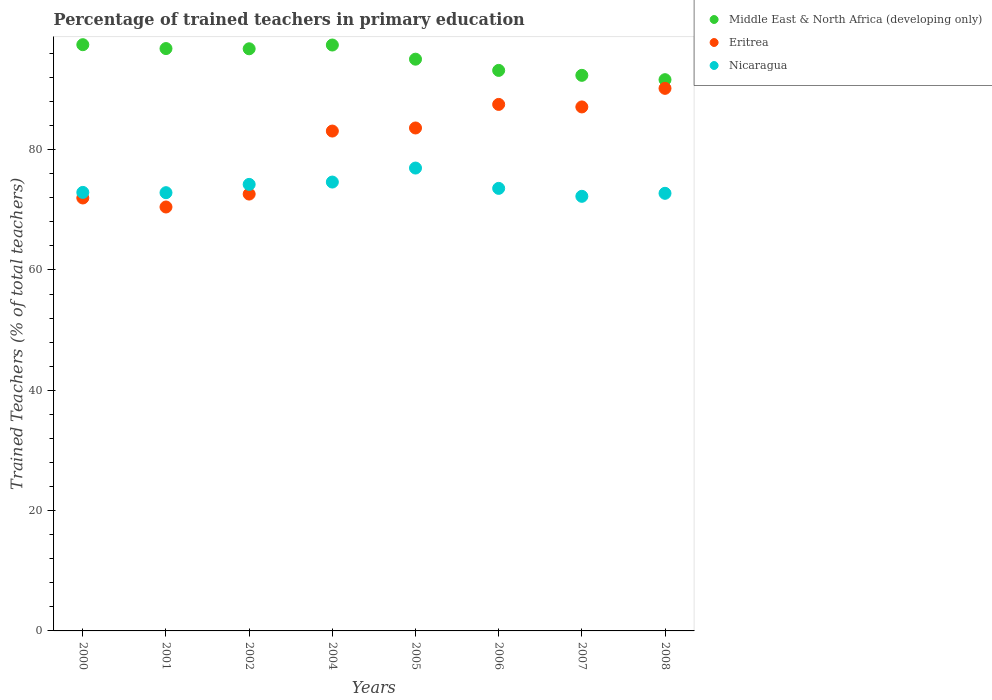What is the percentage of trained teachers in Nicaragua in 2002?
Provide a succinct answer. 74.23. Across all years, what is the maximum percentage of trained teachers in Middle East & North Africa (developing only)?
Offer a terse response. 97.45. Across all years, what is the minimum percentage of trained teachers in Eritrea?
Offer a terse response. 70.47. In which year was the percentage of trained teachers in Middle East & North Africa (developing only) minimum?
Your response must be concise. 2008. What is the total percentage of trained teachers in Middle East & North Africa (developing only) in the graph?
Give a very brief answer. 760.64. What is the difference between the percentage of trained teachers in Nicaragua in 2005 and that in 2007?
Your response must be concise. 4.7. What is the difference between the percentage of trained teachers in Nicaragua in 2006 and the percentage of trained teachers in Middle East & North Africa (developing only) in 2008?
Offer a terse response. -18.07. What is the average percentage of trained teachers in Nicaragua per year?
Keep it short and to the point. 73.76. In the year 2002, what is the difference between the percentage of trained teachers in Middle East & North Africa (developing only) and percentage of trained teachers in Nicaragua?
Ensure brevity in your answer.  22.54. What is the ratio of the percentage of trained teachers in Eritrea in 2000 to that in 2001?
Your response must be concise. 1.02. What is the difference between the highest and the second highest percentage of trained teachers in Middle East & North Africa (developing only)?
Keep it short and to the point. 0.06. What is the difference between the highest and the lowest percentage of trained teachers in Middle East & North Africa (developing only)?
Ensure brevity in your answer.  5.82. In how many years, is the percentage of trained teachers in Eritrea greater than the average percentage of trained teachers in Eritrea taken over all years?
Provide a succinct answer. 5. Is the sum of the percentage of trained teachers in Nicaragua in 2005 and 2008 greater than the maximum percentage of trained teachers in Middle East & North Africa (developing only) across all years?
Give a very brief answer. Yes. How many dotlines are there?
Make the answer very short. 3. How many years are there in the graph?
Provide a succinct answer. 8. Are the values on the major ticks of Y-axis written in scientific E-notation?
Offer a terse response. No. Does the graph contain grids?
Provide a succinct answer. No. Where does the legend appear in the graph?
Ensure brevity in your answer.  Top right. How many legend labels are there?
Give a very brief answer. 3. What is the title of the graph?
Offer a very short reply. Percentage of trained teachers in primary education. What is the label or title of the Y-axis?
Offer a very short reply. Trained Teachers (% of total teachers). What is the Trained Teachers (% of total teachers) in Middle East & North Africa (developing only) in 2000?
Ensure brevity in your answer.  97.45. What is the Trained Teachers (% of total teachers) of Eritrea in 2000?
Offer a terse response. 71.97. What is the Trained Teachers (% of total teachers) of Nicaragua in 2000?
Make the answer very short. 72.9. What is the Trained Teachers (% of total teachers) in Middle East & North Africa (developing only) in 2001?
Offer a terse response. 96.81. What is the Trained Teachers (% of total teachers) of Eritrea in 2001?
Your answer should be very brief. 70.47. What is the Trained Teachers (% of total teachers) of Nicaragua in 2001?
Make the answer very short. 72.85. What is the Trained Teachers (% of total teachers) of Middle East & North Africa (developing only) in 2002?
Offer a terse response. 96.77. What is the Trained Teachers (% of total teachers) of Eritrea in 2002?
Offer a terse response. 72.62. What is the Trained Teachers (% of total teachers) of Nicaragua in 2002?
Your answer should be compact. 74.23. What is the Trained Teachers (% of total teachers) in Middle East & North Africa (developing only) in 2004?
Give a very brief answer. 97.4. What is the Trained Teachers (% of total teachers) of Eritrea in 2004?
Your response must be concise. 83.09. What is the Trained Teachers (% of total teachers) in Nicaragua in 2004?
Provide a succinct answer. 74.62. What is the Trained Teachers (% of total teachers) of Middle East & North Africa (developing only) in 2005?
Make the answer very short. 95.04. What is the Trained Teachers (% of total teachers) in Eritrea in 2005?
Make the answer very short. 83.61. What is the Trained Teachers (% of total teachers) of Nicaragua in 2005?
Keep it short and to the point. 76.94. What is the Trained Teachers (% of total teachers) in Middle East & North Africa (developing only) in 2006?
Give a very brief answer. 93.18. What is the Trained Teachers (% of total teachers) in Eritrea in 2006?
Make the answer very short. 87.52. What is the Trained Teachers (% of total teachers) in Nicaragua in 2006?
Give a very brief answer. 73.57. What is the Trained Teachers (% of total teachers) in Middle East & North Africa (developing only) in 2007?
Offer a very short reply. 92.36. What is the Trained Teachers (% of total teachers) in Eritrea in 2007?
Provide a succinct answer. 87.11. What is the Trained Teachers (% of total teachers) in Nicaragua in 2007?
Provide a short and direct response. 72.25. What is the Trained Teachers (% of total teachers) of Middle East & North Africa (developing only) in 2008?
Offer a very short reply. 91.64. What is the Trained Teachers (% of total teachers) of Eritrea in 2008?
Provide a succinct answer. 90.19. What is the Trained Teachers (% of total teachers) in Nicaragua in 2008?
Offer a very short reply. 72.74. Across all years, what is the maximum Trained Teachers (% of total teachers) of Middle East & North Africa (developing only)?
Give a very brief answer. 97.45. Across all years, what is the maximum Trained Teachers (% of total teachers) in Eritrea?
Give a very brief answer. 90.19. Across all years, what is the maximum Trained Teachers (% of total teachers) in Nicaragua?
Make the answer very short. 76.94. Across all years, what is the minimum Trained Teachers (% of total teachers) of Middle East & North Africa (developing only)?
Make the answer very short. 91.64. Across all years, what is the minimum Trained Teachers (% of total teachers) in Eritrea?
Keep it short and to the point. 70.47. Across all years, what is the minimum Trained Teachers (% of total teachers) of Nicaragua?
Offer a terse response. 72.25. What is the total Trained Teachers (% of total teachers) of Middle East & North Africa (developing only) in the graph?
Make the answer very short. 760.64. What is the total Trained Teachers (% of total teachers) of Eritrea in the graph?
Provide a succinct answer. 646.58. What is the total Trained Teachers (% of total teachers) of Nicaragua in the graph?
Make the answer very short. 590.09. What is the difference between the Trained Teachers (% of total teachers) of Middle East & North Africa (developing only) in 2000 and that in 2001?
Your response must be concise. 0.64. What is the difference between the Trained Teachers (% of total teachers) of Eritrea in 2000 and that in 2001?
Give a very brief answer. 1.5. What is the difference between the Trained Teachers (% of total teachers) in Nicaragua in 2000 and that in 2001?
Your answer should be very brief. 0.05. What is the difference between the Trained Teachers (% of total teachers) of Middle East & North Africa (developing only) in 2000 and that in 2002?
Provide a succinct answer. 0.68. What is the difference between the Trained Teachers (% of total teachers) in Eritrea in 2000 and that in 2002?
Ensure brevity in your answer.  -0.65. What is the difference between the Trained Teachers (% of total teachers) of Nicaragua in 2000 and that in 2002?
Your answer should be compact. -1.33. What is the difference between the Trained Teachers (% of total teachers) of Middle East & North Africa (developing only) in 2000 and that in 2004?
Your answer should be compact. 0.06. What is the difference between the Trained Teachers (% of total teachers) in Eritrea in 2000 and that in 2004?
Give a very brief answer. -11.12. What is the difference between the Trained Teachers (% of total teachers) in Nicaragua in 2000 and that in 2004?
Keep it short and to the point. -1.72. What is the difference between the Trained Teachers (% of total teachers) in Middle East & North Africa (developing only) in 2000 and that in 2005?
Make the answer very short. 2.41. What is the difference between the Trained Teachers (% of total teachers) of Eritrea in 2000 and that in 2005?
Make the answer very short. -11.64. What is the difference between the Trained Teachers (% of total teachers) of Nicaragua in 2000 and that in 2005?
Keep it short and to the point. -4.05. What is the difference between the Trained Teachers (% of total teachers) in Middle East & North Africa (developing only) in 2000 and that in 2006?
Your response must be concise. 4.27. What is the difference between the Trained Teachers (% of total teachers) in Eritrea in 2000 and that in 2006?
Your answer should be compact. -15.55. What is the difference between the Trained Teachers (% of total teachers) of Nicaragua in 2000 and that in 2006?
Offer a terse response. -0.67. What is the difference between the Trained Teachers (% of total teachers) of Middle East & North Africa (developing only) in 2000 and that in 2007?
Your response must be concise. 5.1. What is the difference between the Trained Teachers (% of total teachers) of Eritrea in 2000 and that in 2007?
Offer a terse response. -15.14. What is the difference between the Trained Teachers (% of total teachers) in Nicaragua in 2000 and that in 2007?
Offer a very short reply. 0.65. What is the difference between the Trained Teachers (% of total teachers) in Middle East & North Africa (developing only) in 2000 and that in 2008?
Provide a succinct answer. 5.82. What is the difference between the Trained Teachers (% of total teachers) in Eritrea in 2000 and that in 2008?
Your response must be concise. -18.22. What is the difference between the Trained Teachers (% of total teachers) in Nicaragua in 2000 and that in 2008?
Your answer should be very brief. 0.15. What is the difference between the Trained Teachers (% of total teachers) of Middle East & North Africa (developing only) in 2001 and that in 2002?
Offer a terse response. 0.04. What is the difference between the Trained Teachers (% of total teachers) of Eritrea in 2001 and that in 2002?
Ensure brevity in your answer.  -2.15. What is the difference between the Trained Teachers (% of total teachers) in Nicaragua in 2001 and that in 2002?
Offer a terse response. -1.38. What is the difference between the Trained Teachers (% of total teachers) of Middle East & North Africa (developing only) in 2001 and that in 2004?
Your answer should be very brief. -0.59. What is the difference between the Trained Teachers (% of total teachers) in Eritrea in 2001 and that in 2004?
Give a very brief answer. -12.62. What is the difference between the Trained Teachers (% of total teachers) of Nicaragua in 2001 and that in 2004?
Offer a terse response. -1.77. What is the difference between the Trained Teachers (% of total teachers) in Middle East & North Africa (developing only) in 2001 and that in 2005?
Offer a very short reply. 1.76. What is the difference between the Trained Teachers (% of total teachers) in Eritrea in 2001 and that in 2005?
Offer a terse response. -13.14. What is the difference between the Trained Teachers (% of total teachers) of Nicaragua in 2001 and that in 2005?
Provide a short and direct response. -4.09. What is the difference between the Trained Teachers (% of total teachers) of Middle East & North Africa (developing only) in 2001 and that in 2006?
Keep it short and to the point. 3.63. What is the difference between the Trained Teachers (% of total teachers) in Eritrea in 2001 and that in 2006?
Your answer should be compact. -17.05. What is the difference between the Trained Teachers (% of total teachers) of Nicaragua in 2001 and that in 2006?
Provide a short and direct response. -0.72. What is the difference between the Trained Teachers (% of total teachers) in Middle East & North Africa (developing only) in 2001 and that in 2007?
Keep it short and to the point. 4.45. What is the difference between the Trained Teachers (% of total teachers) of Eritrea in 2001 and that in 2007?
Your response must be concise. -16.63. What is the difference between the Trained Teachers (% of total teachers) of Nicaragua in 2001 and that in 2007?
Provide a succinct answer. 0.6. What is the difference between the Trained Teachers (% of total teachers) of Middle East & North Africa (developing only) in 2001 and that in 2008?
Keep it short and to the point. 5.17. What is the difference between the Trained Teachers (% of total teachers) in Eritrea in 2001 and that in 2008?
Offer a terse response. -19.72. What is the difference between the Trained Teachers (% of total teachers) in Nicaragua in 2001 and that in 2008?
Offer a terse response. 0.11. What is the difference between the Trained Teachers (% of total teachers) of Middle East & North Africa (developing only) in 2002 and that in 2004?
Your answer should be compact. -0.63. What is the difference between the Trained Teachers (% of total teachers) in Eritrea in 2002 and that in 2004?
Your answer should be compact. -10.48. What is the difference between the Trained Teachers (% of total teachers) in Nicaragua in 2002 and that in 2004?
Provide a succinct answer. -0.39. What is the difference between the Trained Teachers (% of total teachers) in Middle East & North Africa (developing only) in 2002 and that in 2005?
Give a very brief answer. 1.73. What is the difference between the Trained Teachers (% of total teachers) in Eritrea in 2002 and that in 2005?
Provide a succinct answer. -10.99. What is the difference between the Trained Teachers (% of total teachers) in Nicaragua in 2002 and that in 2005?
Provide a succinct answer. -2.72. What is the difference between the Trained Teachers (% of total teachers) of Middle East & North Africa (developing only) in 2002 and that in 2006?
Offer a terse response. 3.59. What is the difference between the Trained Teachers (% of total teachers) of Eritrea in 2002 and that in 2006?
Offer a terse response. -14.9. What is the difference between the Trained Teachers (% of total teachers) of Nicaragua in 2002 and that in 2006?
Make the answer very short. 0.66. What is the difference between the Trained Teachers (% of total teachers) in Middle East & North Africa (developing only) in 2002 and that in 2007?
Your answer should be compact. 4.41. What is the difference between the Trained Teachers (% of total teachers) in Eritrea in 2002 and that in 2007?
Offer a terse response. -14.49. What is the difference between the Trained Teachers (% of total teachers) in Nicaragua in 2002 and that in 2007?
Ensure brevity in your answer.  1.98. What is the difference between the Trained Teachers (% of total teachers) in Middle East & North Africa (developing only) in 2002 and that in 2008?
Give a very brief answer. 5.13. What is the difference between the Trained Teachers (% of total teachers) in Eritrea in 2002 and that in 2008?
Provide a short and direct response. -17.57. What is the difference between the Trained Teachers (% of total teachers) of Nicaragua in 2002 and that in 2008?
Provide a succinct answer. 1.48. What is the difference between the Trained Teachers (% of total teachers) of Middle East & North Africa (developing only) in 2004 and that in 2005?
Offer a very short reply. 2.35. What is the difference between the Trained Teachers (% of total teachers) in Eritrea in 2004 and that in 2005?
Make the answer very short. -0.51. What is the difference between the Trained Teachers (% of total teachers) in Nicaragua in 2004 and that in 2005?
Your answer should be compact. -2.33. What is the difference between the Trained Teachers (% of total teachers) of Middle East & North Africa (developing only) in 2004 and that in 2006?
Your response must be concise. 4.22. What is the difference between the Trained Teachers (% of total teachers) in Eritrea in 2004 and that in 2006?
Offer a very short reply. -4.43. What is the difference between the Trained Teachers (% of total teachers) in Nicaragua in 2004 and that in 2006?
Ensure brevity in your answer.  1.05. What is the difference between the Trained Teachers (% of total teachers) of Middle East & North Africa (developing only) in 2004 and that in 2007?
Give a very brief answer. 5.04. What is the difference between the Trained Teachers (% of total teachers) of Eritrea in 2004 and that in 2007?
Your response must be concise. -4.01. What is the difference between the Trained Teachers (% of total teachers) in Nicaragua in 2004 and that in 2007?
Give a very brief answer. 2.37. What is the difference between the Trained Teachers (% of total teachers) of Middle East & North Africa (developing only) in 2004 and that in 2008?
Provide a succinct answer. 5.76. What is the difference between the Trained Teachers (% of total teachers) of Eritrea in 2004 and that in 2008?
Give a very brief answer. -7.1. What is the difference between the Trained Teachers (% of total teachers) in Nicaragua in 2004 and that in 2008?
Your response must be concise. 1.87. What is the difference between the Trained Teachers (% of total teachers) of Middle East & North Africa (developing only) in 2005 and that in 2006?
Make the answer very short. 1.86. What is the difference between the Trained Teachers (% of total teachers) in Eritrea in 2005 and that in 2006?
Give a very brief answer. -3.92. What is the difference between the Trained Teachers (% of total teachers) in Nicaragua in 2005 and that in 2006?
Keep it short and to the point. 3.38. What is the difference between the Trained Teachers (% of total teachers) in Middle East & North Africa (developing only) in 2005 and that in 2007?
Offer a very short reply. 2.69. What is the difference between the Trained Teachers (% of total teachers) in Eritrea in 2005 and that in 2007?
Offer a terse response. -3.5. What is the difference between the Trained Teachers (% of total teachers) of Nicaragua in 2005 and that in 2007?
Offer a very short reply. 4.7. What is the difference between the Trained Teachers (% of total teachers) of Middle East & North Africa (developing only) in 2005 and that in 2008?
Make the answer very short. 3.41. What is the difference between the Trained Teachers (% of total teachers) of Eritrea in 2005 and that in 2008?
Ensure brevity in your answer.  -6.59. What is the difference between the Trained Teachers (% of total teachers) of Nicaragua in 2005 and that in 2008?
Provide a succinct answer. 4.2. What is the difference between the Trained Teachers (% of total teachers) of Middle East & North Africa (developing only) in 2006 and that in 2007?
Give a very brief answer. 0.82. What is the difference between the Trained Teachers (% of total teachers) in Eritrea in 2006 and that in 2007?
Provide a short and direct response. 0.42. What is the difference between the Trained Teachers (% of total teachers) in Nicaragua in 2006 and that in 2007?
Your answer should be compact. 1.32. What is the difference between the Trained Teachers (% of total teachers) in Middle East & North Africa (developing only) in 2006 and that in 2008?
Ensure brevity in your answer.  1.54. What is the difference between the Trained Teachers (% of total teachers) in Eritrea in 2006 and that in 2008?
Provide a succinct answer. -2.67. What is the difference between the Trained Teachers (% of total teachers) in Nicaragua in 2006 and that in 2008?
Offer a terse response. 0.82. What is the difference between the Trained Teachers (% of total teachers) of Middle East & North Africa (developing only) in 2007 and that in 2008?
Provide a short and direct response. 0.72. What is the difference between the Trained Teachers (% of total teachers) in Eritrea in 2007 and that in 2008?
Give a very brief answer. -3.09. What is the difference between the Trained Teachers (% of total teachers) in Nicaragua in 2007 and that in 2008?
Give a very brief answer. -0.5. What is the difference between the Trained Teachers (% of total teachers) of Middle East & North Africa (developing only) in 2000 and the Trained Teachers (% of total teachers) of Eritrea in 2001?
Provide a short and direct response. 26.98. What is the difference between the Trained Teachers (% of total teachers) in Middle East & North Africa (developing only) in 2000 and the Trained Teachers (% of total teachers) in Nicaragua in 2001?
Keep it short and to the point. 24.6. What is the difference between the Trained Teachers (% of total teachers) in Eritrea in 2000 and the Trained Teachers (% of total teachers) in Nicaragua in 2001?
Your answer should be very brief. -0.88. What is the difference between the Trained Teachers (% of total teachers) of Middle East & North Africa (developing only) in 2000 and the Trained Teachers (% of total teachers) of Eritrea in 2002?
Provide a short and direct response. 24.83. What is the difference between the Trained Teachers (% of total teachers) of Middle East & North Africa (developing only) in 2000 and the Trained Teachers (% of total teachers) of Nicaragua in 2002?
Make the answer very short. 23.22. What is the difference between the Trained Teachers (% of total teachers) of Eritrea in 2000 and the Trained Teachers (% of total teachers) of Nicaragua in 2002?
Offer a very short reply. -2.26. What is the difference between the Trained Teachers (% of total teachers) of Middle East & North Africa (developing only) in 2000 and the Trained Teachers (% of total teachers) of Eritrea in 2004?
Provide a succinct answer. 14.36. What is the difference between the Trained Teachers (% of total teachers) in Middle East & North Africa (developing only) in 2000 and the Trained Teachers (% of total teachers) in Nicaragua in 2004?
Provide a succinct answer. 22.84. What is the difference between the Trained Teachers (% of total teachers) in Eritrea in 2000 and the Trained Teachers (% of total teachers) in Nicaragua in 2004?
Your response must be concise. -2.65. What is the difference between the Trained Teachers (% of total teachers) of Middle East & North Africa (developing only) in 2000 and the Trained Teachers (% of total teachers) of Eritrea in 2005?
Offer a terse response. 13.85. What is the difference between the Trained Teachers (% of total teachers) of Middle East & North Africa (developing only) in 2000 and the Trained Teachers (% of total teachers) of Nicaragua in 2005?
Provide a succinct answer. 20.51. What is the difference between the Trained Teachers (% of total teachers) of Eritrea in 2000 and the Trained Teachers (% of total teachers) of Nicaragua in 2005?
Offer a very short reply. -4.98. What is the difference between the Trained Teachers (% of total teachers) of Middle East & North Africa (developing only) in 2000 and the Trained Teachers (% of total teachers) of Eritrea in 2006?
Your response must be concise. 9.93. What is the difference between the Trained Teachers (% of total teachers) in Middle East & North Africa (developing only) in 2000 and the Trained Teachers (% of total teachers) in Nicaragua in 2006?
Give a very brief answer. 23.89. What is the difference between the Trained Teachers (% of total teachers) in Eritrea in 2000 and the Trained Teachers (% of total teachers) in Nicaragua in 2006?
Your answer should be very brief. -1.6. What is the difference between the Trained Teachers (% of total teachers) in Middle East & North Africa (developing only) in 2000 and the Trained Teachers (% of total teachers) in Eritrea in 2007?
Give a very brief answer. 10.35. What is the difference between the Trained Teachers (% of total teachers) of Middle East & North Africa (developing only) in 2000 and the Trained Teachers (% of total teachers) of Nicaragua in 2007?
Offer a very short reply. 25.21. What is the difference between the Trained Teachers (% of total teachers) of Eritrea in 2000 and the Trained Teachers (% of total teachers) of Nicaragua in 2007?
Offer a very short reply. -0.28. What is the difference between the Trained Teachers (% of total teachers) in Middle East & North Africa (developing only) in 2000 and the Trained Teachers (% of total teachers) in Eritrea in 2008?
Your response must be concise. 7.26. What is the difference between the Trained Teachers (% of total teachers) in Middle East & North Africa (developing only) in 2000 and the Trained Teachers (% of total teachers) in Nicaragua in 2008?
Your response must be concise. 24.71. What is the difference between the Trained Teachers (% of total teachers) of Eritrea in 2000 and the Trained Teachers (% of total teachers) of Nicaragua in 2008?
Your answer should be very brief. -0.77. What is the difference between the Trained Teachers (% of total teachers) in Middle East & North Africa (developing only) in 2001 and the Trained Teachers (% of total teachers) in Eritrea in 2002?
Keep it short and to the point. 24.19. What is the difference between the Trained Teachers (% of total teachers) of Middle East & North Africa (developing only) in 2001 and the Trained Teachers (% of total teachers) of Nicaragua in 2002?
Your response must be concise. 22.58. What is the difference between the Trained Teachers (% of total teachers) in Eritrea in 2001 and the Trained Teachers (% of total teachers) in Nicaragua in 2002?
Give a very brief answer. -3.76. What is the difference between the Trained Teachers (% of total teachers) of Middle East & North Africa (developing only) in 2001 and the Trained Teachers (% of total teachers) of Eritrea in 2004?
Your response must be concise. 13.71. What is the difference between the Trained Teachers (% of total teachers) in Middle East & North Africa (developing only) in 2001 and the Trained Teachers (% of total teachers) in Nicaragua in 2004?
Offer a very short reply. 22.19. What is the difference between the Trained Teachers (% of total teachers) of Eritrea in 2001 and the Trained Teachers (% of total teachers) of Nicaragua in 2004?
Offer a terse response. -4.15. What is the difference between the Trained Teachers (% of total teachers) in Middle East & North Africa (developing only) in 2001 and the Trained Teachers (% of total teachers) in Eritrea in 2005?
Give a very brief answer. 13.2. What is the difference between the Trained Teachers (% of total teachers) in Middle East & North Africa (developing only) in 2001 and the Trained Teachers (% of total teachers) in Nicaragua in 2005?
Your response must be concise. 19.86. What is the difference between the Trained Teachers (% of total teachers) in Eritrea in 2001 and the Trained Teachers (% of total teachers) in Nicaragua in 2005?
Your response must be concise. -6.47. What is the difference between the Trained Teachers (% of total teachers) of Middle East & North Africa (developing only) in 2001 and the Trained Teachers (% of total teachers) of Eritrea in 2006?
Your answer should be compact. 9.28. What is the difference between the Trained Teachers (% of total teachers) of Middle East & North Africa (developing only) in 2001 and the Trained Teachers (% of total teachers) of Nicaragua in 2006?
Your answer should be compact. 23.24. What is the difference between the Trained Teachers (% of total teachers) of Eritrea in 2001 and the Trained Teachers (% of total teachers) of Nicaragua in 2006?
Offer a terse response. -3.1. What is the difference between the Trained Teachers (% of total teachers) in Middle East & North Africa (developing only) in 2001 and the Trained Teachers (% of total teachers) in Eritrea in 2007?
Your answer should be compact. 9.7. What is the difference between the Trained Teachers (% of total teachers) of Middle East & North Africa (developing only) in 2001 and the Trained Teachers (% of total teachers) of Nicaragua in 2007?
Ensure brevity in your answer.  24.56. What is the difference between the Trained Teachers (% of total teachers) in Eritrea in 2001 and the Trained Teachers (% of total teachers) in Nicaragua in 2007?
Offer a terse response. -1.77. What is the difference between the Trained Teachers (% of total teachers) of Middle East & North Africa (developing only) in 2001 and the Trained Teachers (% of total teachers) of Eritrea in 2008?
Ensure brevity in your answer.  6.61. What is the difference between the Trained Teachers (% of total teachers) in Middle East & North Africa (developing only) in 2001 and the Trained Teachers (% of total teachers) in Nicaragua in 2008?
Offer a terse response. 24.06. What is the difference between the Trained Teachers (% of total teachers) of Eritrea in 2001 and the Trained Teachers (% of total teachers) of Nicaragua in 2008?
Offer a very short reply. -2.27. What is the difference between the Trained Teachers (% of total teachers) of Middle East & North Africa (developing only) in 2002 and the Trained Teachers (% of total teachers) of Eritrea in 2004?
Offer a very short reply. 13.68. What is the difference between the Trained Teachers (% of total teachers) of Middle East & North Africa (developing only) in 2002 and the Trained Teachers (% of total teachers) of Nicaragua in 2004?
Offer a very short reply. 22.15. What is the difference between the Trained Teachers (% of total teachers) of Eritrea in 2002 and the Trained Teachers (% of total teachers) of Nicaragua in 2004?
Your answer should be compact. -2. What is the difference between the Trained Teachers (% of total teachers) of Middle East & North Africa (developing only) in 2002 and the Trained Teachers (% of total teachers) of Eritrea in 2005?
Your answer should be very brief. 13.16. What is the difference between the Trained Teachers (% of total teachers) of Middle East & North Africa (developing only) in 2002 and the Trained Teachers (% of total teachers) of Nicaragua in 2005?
Provide a succinct answer. 19.83. What is the difference between the Trained Teachers (% of total teachers) in Eritrea in 2002 and the Trained Teachers (% of total teachers) in Nicaragua in 2005?
Ensure brevity in your answer.  -4.33. What is the difference between the Trained Teachers (% of total teachers) of Middle East & North Africa (developing only) in 2002 and the Trained Teachers (% of total teachers) of Eritrea in 2006?
Your answer should be compact. 9.25. What is the difference between the Trained Teachers (% of total teachers) in Middle East & North Africa (developing only) in 2002 and the Trained Teachers (% of total teachers) in Nicaragua in 2006?
Make the answer very short. 23.2. What is the difference between the Trained Teachers (% of total teachers) in Eritrea in 2002 and the Trained Teachers (% of total teachers) in Nicaragua in 2006?
Offer a terse response. -0.95. What is the difference between the Trained Teachers (% of total teachers) in Middle East & North Africa (developing only) in 2002 and the Trained Teachers (% of total teachers) in Eritrea in 2007?
Make the answer very short. 9.67. What is the difference between the Trained Teachers (% of total teachers) in Middle East & North Africa (developing only) in 2002 and the Trained Teachers (% of total teachers) in Nicaragua in 2007?
Your answer should be very brief. 24.52. What is the difference between the Trained Teachers (% of total teachers) in Eritrea in 2002 and the Trained Teachers (% of total teachers) in Nicaragua in 2007?
Give a very brief answer. 0.37. What is the difference between the Trained Teachers (% of total teachers) in Middle East & North Africa (developing only) in 2002 and the Trained Teachers (% of total teachers) in Eritrea in 2008?
Keep it short and to the point. 6.58. What is the difference between the Trained Teachers (% of total teachers) of Middle East & North Africa (developing only) in 2002 and the Trained Teachers (% of total teachers) of Nicaragua in 2008?
Your answer should be compact. 24.03. What is the difference between the Trained Teachers (% of total teachers) in Eritrea in 2002 and the Trained Teachers (% of total teachers) in Nicaragua in 2008?
Your response must be concise. -0.12. What is the difference between the Trained Teachers (% of total teachers) of Middle East & North Africa (developing only) in 2004 and the Trained Teachers (% of total teachers) of Eritrea in 2005?
Provide a short and direct response. 13.79. What is the difference between the Trained Teachers (% of total teachers) of Middle East & North Africa (developing only) in 2004 and the Trained Teachers (% of total teachers) of Nicaragua in 2005?
Your response must be concise. 20.45. What is the difference between the Trained Teachers (% of total teachers) in Eritrea in 2004 and the Trained Teachers (% of total teachers) in Nicaragua in 2005?
Ensure brevity in your answer.  6.15. What is the difference between the Trained Teachers (% of total teachers) of Middle East & North Africa (developing only) in 2004 and the Trained Teachers (% of total teachers) of Eritrea in 2006?
Your response must be concise. 9.87. What is the difference between the Trained Teachers (% of total teachers) in Middle East & North Africa (developing only) in 2004 and the Trained Teachers (% of total teachers) in Nicaragua in 2006?
Give a very brief answer. 23.83. What is the difference between the Trained Teachers (% of total teachers) in Eritrea in 2004 and the Trained Teachers (% of total teachers) in Nicaragua in 2006?
Make the answer very short. 9.53. What is the difference between the Trained Teachers (% of total teachers) in Middle East & North Africa (developing only) in 2004 and the Trained Teachers (% of total teachers) in Eritrea in 2007?
Your response must be concise. 10.29. What is the difference between the Trained Teachers (% of total teachers) of Middle East & North Africa (developing only) in 2004 and the Trained Teachers (% of total teachers) of Nicaragua in 2007?
Provide a succinct answer. 25.15. What is the difference between the Trained Teachers (% of total teachers) in Eritrea in 2004 and the Trained Teachers (% of total teachers) in Nicaragua in 2007?
Give a very brief answer. 10.85. What is the difference between the Trained Teachers (% of total teachers) in Middle East & North Africa (developing only) in 2004 and the Trained Teachers (% of total teachers) in Eritrea in 2008?
Keep it short and to the point. 7.2. What is the difference between the Trained Teachers (% of total teachers) in Middle East & North Africa (developing only) in 2004 and the Trained Teachers (% of total teachers) in Nicaragua in 2008?
Give a very brief answer. 24.65. What is the difference between the Trained Teachers (% of total teachers) in Eritrea in 2004 and the Trained Teachers (% of total teachers) in Nicaragua in 2008?
Offer a very short reply. 10.35. What is the difference between the Trained Teachers (% of total teachers) in Middle East & North Africa (developing only) in 2005 and the Trained Teachers (% of total teachers) in Eritrea in 2006?
Your answer should be very brief. 7.52. What is the difference between the Trained Teachers (% of total teachers) of Middle East & North Africa (developing only) in 2005 and the Trained Teachers (% of total teachers) of Nicaragua in 2006?
Your answer should be very brief. 21.48. What is the difference between the Trained Teachers (% of total teachers) in Eritrea in 2005 and the Trained Teachers (% of total teachers) in Nicaragua in 2006?
Provide a succinct answer. 10.04. What is the difference between the Trained Teachers (% of total teachers) in Middle East & North Africa (developing only) in 2005 and the Trained Teachers (% of total teachers) in Eritrea in 2007?
Your response must be concise. 7.94. What is the difference between the Trained Teachers (% of total teachers) in Middle East & North Africa (developing only) in 2005 and the Trained Teachers (% of total teachers) in Nicaragua in 2007?
Your answer should be very brief. 22.8. What is the difference between the Trained Teachers (% of total teachers) in Eritrea in 2005 and the Trained Teachers (% of total teachers) in Nicaragua in 2007?
Offer a very short reply. 11.36. What is the difference between the Trained Teachers (% of total teachers) of Middle East & North Africa (developing only) in 2005 and the Trained Teachers (% of total teachers) of Eritrea in 2008?
Provide a succinct answer. 4.85. What is the difference between the Trained Teachers (% of total teachers) of Middle East & North Africa (developing only) in 2005 and the Trained Teachers (% of total teachers) of Nicaragua in 2008?
Provide a short and direct response. 22.3. What is the difference between the Trained Teachers (% of total teachers) in Eritrea in 2005 and the Trained Teachers (% of total teachers) in Nicaragua in 2008?
Your answer should be compact. 10.86. What is the difference between the Trained Teachers (% of total teachers) in Middle East & North Africa (developing only) in 2006 and the Trained Teachers (% of total teachers) in Eritrea in 2007?
Ensure brevity in your answer.  6.07. What is the difference between the Trained Teachers (% of total teachers) in Middle East & North Africa (developing only) in 2006 and the Trained Teachers (% of total teachers) in Nicaragua in 2007?
Provide a succinct answer. 20.93. What is the difference between the Trained Teachers (% of total teachers) in Eritrea in 2006 and the Trained Teachers (% of total teachers) in Nicaragua in 2007?
Offer a very short reply. 15.28. What is the difference between the Trained Teachers (% of total teachers) of Middle East & North Africa (developing only) in 2006 and the Trained Teachers (% of total teachers) of Eritrea in 2008?
Offer a terse response. 2.99. What is the difference between the Trained Teachers (% of total teachers) of Middle East & North Africa (developing only) in 2006 and the Trained Teachers (% of total teachers) of Nicaragua in 2008?
Give a very brief answer. 20.43. What is the difference between the Trained Teachers (% of total teachers) of Eritrea in 2006 and the Trained Teachers (% of total teachers) of Nicaragua in 2008?
Give a very brief answer. 14.78. What is the difference between the Trained Teachers (% of total teachers) of Middle East & North Africa (developing only) in 2007 and the Trained Teachers (% of total teachers) of Eritrea in 2008?
Ensure brevity in your answer.  2.16. What is the difference between the Trained Teachers (% of total teachers) in Middle East & North Africa (developing only) in 2007 and the Trained Teachers (% of total teachers) in Nicaragua in 2008?
Your response must be concise. 19.61. What is the difference between the Trained Teachers (% of total teachers) in Eritrea in 2007 and the Trained Teachers (% of total teachers) in Nicaragua in 2008?
Keep it short and to the point. 14.36. What is the average Trained Teachers (% of total teachers) of Middle East & North Africa (developing only) per year?
Your answer should be very brief. 95.08. What is the average Trained Teachers (% of total teachers) in Eritrea per year?
Make the answer very short. 80.82. What is the average Trained Teachers (% of total teachers) of Nicaragua per year?
Keep it short and to the point. 73.76. In the year 2000, what is the difference between the Trained Teachers (% of total teachers) in Middle East & North Africa (developing only) and Trained Teachers (% of total teachers) in Eritrea?
Offer a very short reply. 25.48. In the year 2000, what is the difference between the Trained Teachers (% of total teachers) in Middle East & North Africa (developing only) and Trained Teachers (% of total teachers) in Nicaragua?
Keep it short and to the point. 24.56. In the year 2000, what is the difference between the Trained Teachers (% of total teachers) in Eritrea and Trained Teachers (% of total teachers) in Nicaragua?
Your answer should be very brief. -0.93. In the year 2001, what is the difference between the Trained Teachers (% of total teachers) in Middle East & North Africa (developing only) and Trained Teachers (% of total teachers) in Eritrea?
Give a very brief answer. 26.34. In the year 2001, what is the difference between the Trained Teachers (% of total teachers) of Middle East & North Africa (developing only) and Trained Teachers (% of total teachers) of Nicaragua?
Your answer should be compact. 23.96. In the year 2001, what is the difference between the Trained Teachers (% of total teachers) of Eritrea and Trained Teachers (% of total teachers) of Nicaragua?
Offer a terse response. -2.38. In the year 2002, what is the difference between the Trained Teachers (% of total teachers) of Middle East & North Africa (developing only) and Trained Teachers (% of total teachers) of Eritrea?
Give a very brief answer. 24.15. In the year 2002, what is the difference between the Trained Teachers (% of total teachers) in Middle East & North Africa (developing only) and Trained Teachers (% of total teachers) in Nicaragua?
Your response must be concise. 22.54. In the year 2002, what is the difference between the Trained Teachers (% of total teachers) of Eritrea and Trained Teachers (% of total teachers) of Nicaragua?
Your response must be concise. -1.61. In the year 2004, what is the difference between the Trained Teachers (% of total teachers) of Middle East & North Africa (developing only) and Trained Teachers (% of total teachers) of Eritrea?
Provide a succinct answer. 14.3. In the year 2004, what is the difference between the Trained Teachers (% of total teachers) of Middle East & North Africa (developing only) and Trained Teachers (% of total teachers) of Nicaragua?
Keep it short and to the point. 22.78. In the year 2004, what is the difference between the Trained Teachers (% of total teachers) of Eritrea and Trained Teachers (% of total teachers) of Nicaragua?
Your answer should be very brief. 8.48. In the year 2005, what is the difference between the Trained Teachers (% of total teachers) of Middle East & North Africa (developing only) and Trained Teachers (% of total teachers) of Eritrea?
Offer a very short reply. 11.44. In the year 2005, what is the difference between the Trained Teachers (% of total teachers) in Middle East & North Africa (developing only) and Trained Teachers (% of total teachers) in Nicaragua?
Provide a succinct answer. 18.1. In the year 2005, what is the difference between the Trained Teachers (% of total teachers) in Eritrea and Trained Teachers (% of total teachers) in Nicaragua?
Give a very brief answer. 6.66. In the year 2006, what is the difference between the Trained Teachers (% of total teachers) of Middle East & North Africa (developing only) and Trained Teachers (% of total teachers) of Eritrea?
Give a very brief answer. 5.65. In the year 2006, what is the difference between the Trained Teachers (% of total teachers) of Middle East & North Africa (developing only) and Trained Teachers (% of total teachers) of Nicaragua?
Your answer should be very brief. 19.61. In the year 2006, what is the difference between the Trained Teachers (% of total teachers) in Eritrea and Trained Teachers (% of total teachers) in Nicaragua?
Give a very brief answer. 13.96. In the year 2007, what is the difference between the Trained Teachers (% of total teachers) in Middle East & North Africa (developing only) and Trained Teachers (% of total teachers) in Eritrea?
Ensure brevity in your answer.  5.25. In the year 2007, what is the difference between the Trained Teachers (% of total teachers) of Middle East & North Africa (developing only) and Trained Teachers (% of total teachers) of Nicaragua?
Give a very brief answer. 20.11. In the year 2007, what is the difference between the Trained Teachers (% of total teachers) of Eritrea and Trained Teachers (% of total teachers) of Nicaragua?
Your response must be concise. 14.86. In the year 2008, what is the difference between the Trained Teachers (% of total teachers) of Middle East & North Africa (developing only) and Trained Teachers (% of total teachers) of Eritrea?
Your answer should be compact. 1.44. In the year 2008, what is the difference between the Trained Teachers (% of total teachers) in Middle East & North Africa (developing only) and Trained Teachers (% of total teachers) in Nicaragua?
Your answer should be compact. 18.89. In the year 2008, what is the difference between the Trained Teachers (% of total teachers) of Eritrea and Trained Teachers (% of total teachers) of Nicaragua?
Your response must be concise. 17.45. What is the ratio of the Trained Teachers (% of total teachers) of Middle East & North Africa (developing only) in 2000 to that in 2001?
Your response must be concise. 1.01. What is the ratio of the Trained Teachers (% of total teachers) of Eritrea in 2000 to that in 2001?
Make the answer very short. 1.02. What is the ratio of the Trained Teachers (% of total teachers) in Eritrea in 2000 to that in 2002?
Offer a terse response. 0.99. What is the ratio of the Trained Teachers (% of total teachers) of Nicaragua in 2000 to that in 2002?
Provide a short and direct response. 0.98. What is the ratio of the Trained Teachers (% of total teachers) of Middle East & North Africa (developing only) in 2000 to that in 2004?
Provide a succinct answer. 1. What is the ratio of the Trained Teachers (% of total teachers) in Eritrea in 2000 to that in 2004?
Ensure brevity in your answer.  0.87. What is the ratio of the Trained Teachers (% of total teachers) in Middle East & North Africa (developing only) in 2000 to that in 2005?
Make the answer very short. 1.03. What is the ratio of the Trained Teachers (% of total teachers) of Eritrea in 2000 to that in 2005?
Provide a short and direct response. 0.86. What is the ratio of the Trained Teachers (% of total teachers) of Middle East & North Africa (developing only) in 2000 to that in 2006?
Keep it short and to the point. 1.05. What is the ratio of the Trained Teachers (% of total teachers) of Eritrea in 2000 to that in 2006?
Provide a short and direct response. 0.82. What is the ratio of the Trained Teachers (% of total teachers) of Nicaragua in 2000 to that in 2006?
Give a very brief answer. 0.99. What is the ratio of the Trained Teachers (% of total teachers) in Middle East & North Africa (developing only) in 2000 to that in 2007?
Offer a very short reply. 1.06. What is the ratio of the Trained Teachers (% of total teachers) in Eritrea in 2000 to that in 2007?
Offer a terse response. 0.83. What is the ratio of the Trained Teachers (% of total teachers) in Nicaragua in 2000 to that in 2007?
Your response must be concise. 1.01. What is the ratio of the Trained Teachers (% of total teachers) in Middle East & North Africa (developing only) in 2000 to that in 2008?
Offer a very short reply. 1.06. What is the ratio of the Trained Teachers (% of total teachers) in Eritrea in 2000 to that in 2008?
Your response must be concise. 0.8. What is the ratio of the Trained Teachers (% of total teachers) of Nicaragua in 2000 to that in 2008?
Offer a terse response. 1. What is the ratio of the Trained Teachers (% of total teachers) of Middle East & North Africa (developing only) in 2001 to that in 2002?
Offer a very short reply. 1. What is the ratio of the Trained Teachers (% of total teachers) of Eritrea in 2001 to that in 2002?
Offer a very short reply. 0.97. What is the ratio of the Trained Teachers (% of total teachers) in Nicaragua in 2001 to that in 2002?
Offer a terse response. 0.98. What is the ratio of the Trained Teachers (% of total teachers) in Eritrea in 2001 to that in 2004?
Ensure brevity in your answer.  0.85. What is the ratio of the Trained Teachers (% of total teachers) in Nicaragua in 2001 to that in 2004?
Make the answer very short. 0.98. What is the ratio of the Trained Teachers (% of total teachers) in Middle East & North Africa (developing only) in 2001 to that in 2005?
Provide a short and direct response. 1.02. What is the ratio of the Trained Teachers (% of total teachers) of Eritrea in 2001 to that in 2005?
Provide a succinct answer. 0.84. What is the ratio of the Trained Teachers (% of total teachers) in Nicaragua in 2001 to that in 2005?
Make the answer very short. 0.95. What is the ratio of the Trained Teachers (% of total teachers) of Middle East & North Africa (developing only) in 2001 to that in 2006?
Make the answer very short. 1.04. What is the ratio of the Trained Teachers (% of total teachers) in Eritrea in 2001 to that in 2006?
Your response must be concise. 0.81. What is the ratio of the Trained Teachers (% of total teachers) of Nicaragua in 2001 to that in 2006?
Provide a short and direct response. 0.99. What is the ratio of the Trained Teachers (% of total teachers) of Middle East & North Africa (developing only) in 2001 to that in 2007?
Give a very brief answer. 1.05. What is the ratio of the Trained Teachers (% of total teachers) of Eritrea in 2001 to that in 2007?
Provide a succinct answer. 0.81. What is the ratio of the Trained Teachers (% of total teachers) of Nicaragua in 2001 to that in 2007?
Provide a short and direct response. 1.01. What is the ratio of the Trained Teachers (% of total teachers) in Middle East & North Africa (developing only) in 2001 to that in 2008?
Offer a very short reply. 1.06. What is the ratio of the Trained Teachers (% of total teachers) of Eritrea in 2001 to that in 2008?
Make the answer very short. 0.78. What is the ratio of the Trained Teachers (% of total teachers) of Nicaragua in 2001 to that in 2008?
Provide a short and direct response. 1. What is the ratio of the Trained Teachers (% of total teachers) of Eritrea in 2002 to that in 2004?
Provide a succinct answer. 0.87. What is the ratio of the Trained Teachers (% of total teachers) in Middle East & North Africa (developing only) in 2002 to that in 2005?
Make the answer very short. 1.02. What is the ratio of the Trained Teachers (% of total teachers) of Eritrea in 2002 to that in 2005?
Offer a terse response. 0.87. What is the ratio of the Trained Teachers (% of total teachers) in Nicaragua in 2002 to that in 2005?
Give a very brief answer. 0.96. What is the ratio of the Trained Teachers (% of total teachers) of Middle East & North Africa (developing only) in 2002 to that in 2006?
Offer a very short reply. 1.04. What is the ratio of the Trained Teachers (% of total teachers) of Eritrea in 2002 to that in 2006?
Your response must be concise. 0.83. What is the ratio of the Trained Teachers (% of total teachers) in Middle East & North Africa (developing only) in 2002 to that in 2007?
Provide a succinct answer. 1.05. What is the ratio of the Trained Teachers (% of total teachers) of Eritrea in 2002 to that in 2007?
Provide a short and direct response. 0.83. What is the ratio of the Trained Teachers (% of total teachers) of Nicaragua in 2002 to that in 2007?
Give a very brief answer. 1.03. What is the ratio of the Trained Teachers (% of total teachers) of Middle East & North Africa (developing only) in 2002 to that in 2008?
Provide a succinct answer. 1.06. What is the ratio of the Trained Teachers (% of total teachers) in Eritrea in 2002 to that in 2008?
Keep it short and to the point. 0.81. What is the ratio of the Trained Teachers (% of total teachers) of Nicaragua in 2002 to that in 2008?
Keep it short and to the point. 1.02. What is the ratio of the Trained Teachers (% of total teachers) of Middle East & North Africa (developing only) in 2004 to that in 2005?
Your answer should be compact. 1.02. What is the ratio of the Trained Teachers (% of total teachers) in Eritrea in 2004 to that in 2005?
Your answer should be very brief. 0.99. What is the ratio of the Trained Teachers (% of total teachers) in Nicaragua in 2004 to that in 2005?
Provide a succinct answer. 0.97. What is the ratio of the Trained Teachers (% of total teachers) in Middle East & North Africa (developing only) in 2004 to that in 2006?
Your response must be concise. 1.05. What is the ratio of the Trained Teachers (% of total teachers) of Eritrea in 2004 to that in 2006?
Make the answer very short. 0.95. What is the ratio of the Trained Teachers (% of total teachers) in Nicaragua in 2004 to that in 2006?
Make the answer very short. 1.01. What is the ratio of the Trained Teachers (% of total teachers) in Middle East & North Africa (developing only) in 2004 to that in 2007?
Provide a succinct answer. 1.05. What is the ratio of the Trained Teachers (% of total teachers) in Eritrea in 2004 to that in 2007?
Offer a very short reply. 0.95. What is the ratio of the Trained Teachers (% of total teachers) in Nicaragua in 2004 to that in 2007?
Give a very brief answer. 1.03. What is the ratio of the Trained Teachers (% of total teachers) of Middle East & North Africa (developing only) in 2004 to that in 2008?
Offer a very short reply. 1.06. What is the ratio of the Trained Teachers (% of total teachers) of Eritrea in 2004 to that in 2008?
Provide a succinct answer. 0.92. What is the ratio of the Trained Teachers (% of total teachers) in Nicaragua in 2004 to that in 2008?
Give a very brief answer. 1.03. What is the ratio of the Trained Teachers (% of total teachers) of Eritrea in 2005 to that in 2006?
Provide a short and direct response. 0.96. What is the ratio of the Trained Teachers (% of total teachers) of Nicaragua in 2005 to that in 2006?
Your answer should be compact. 1.05. What is the ratio of the Trained Teachers (% of total teachers) in Middle East & North Africa (developing only) in 2005 to that in 2007?
Provide a short and direct response. 1.03. What is the ratio of the Trained Teachers (% of total teachers) of Eritrea in 2005 to that in 2007?
Keep it short and to the point. 0.96. What is the ratio of the Trained Teachers (% of total teachers) in Nicaragua in 2005 to that in 2007?
Offer a terse response. 1.06. What is the ratio of the Trained Teachers (% of total teachers) in Middle East & North Africa (developing only) in 2005 to that in 2008?
Your response must be concise. 1.04. What is the ratio of the Trained Teachers (% of total teachers) in Eritrea in 2005 to that in 2008?
Make the answer very short. 0.93. What is the ratio of the Trained Teachers (% of total teachers) of Nicaragua in 2005 to that in 2008?
Give a very brief answer. 1.06. What is the ratio of the Trained Teachers (% of total teachers) in Middle East & North Africa (developing only) in 2006 to that in 2007?
Offer a terse response. 1.01. What is the ratio of the Trained Teachers (% of total teachers) in Nicaragua in 2006 to that in 2007?
Make the answer very short. 1.02. What is the ratio of the Trained Teachers (% of total teachers) of Middle East & North Africa (developing only) in 2006 to that in 2008?
Your answer should be very brief. 1.02. What is the ratio of the Trained Teachers (% of total teachers) of Eritrea in 2006 to that in 2008?
Keep it short and to the point. 0.97. What is the ratio of the Trained Teachers (% of total teachers) in Nicaragua in 2006 to that in 2008?
Provide a short and direct response. 1.01. What is the ratio of the Trained Teachers (% of total teachers) of Middle East & North Africa (developing only) in 2007 to that in 2008?
Give a very brief answer. 1.01. What is the ratio of the Trained Teachers (% of total teachers) in Eritrea in 2007 to that in 2008?
Your response must be concise. 0.97. What is the difference between the highest and the second highest Trained Teachers (% of total teachers) in Middle East & North Africa (developing only)?
Give a very brief answer. 0.06. What is the difference between the highest and the second highest Trained Teachers (% of total teachers) in Eritrea?
Ensure brevity in your answer.  2.67. What is the difference between the highest and the second highest Trained Teachers (% of total teachers) of Nicaragua?
Ensure brevity in your answer.  2.33. What is the difference between the highest and the lowest Trained Teachers (% of total teachers) of Middle East & North Africa (developing only)?
Your answer should be very brief. 5.82. What is the difference between the highest and the lowest Trained Teachers (% of total teachers) in Eritrea?
Keep it short and to the point. 19.72. What is the difference between the highest and the lowest Trained Teachers (% of total teachers) of Nicaragua?
Give a very brief answer. 4.7. 